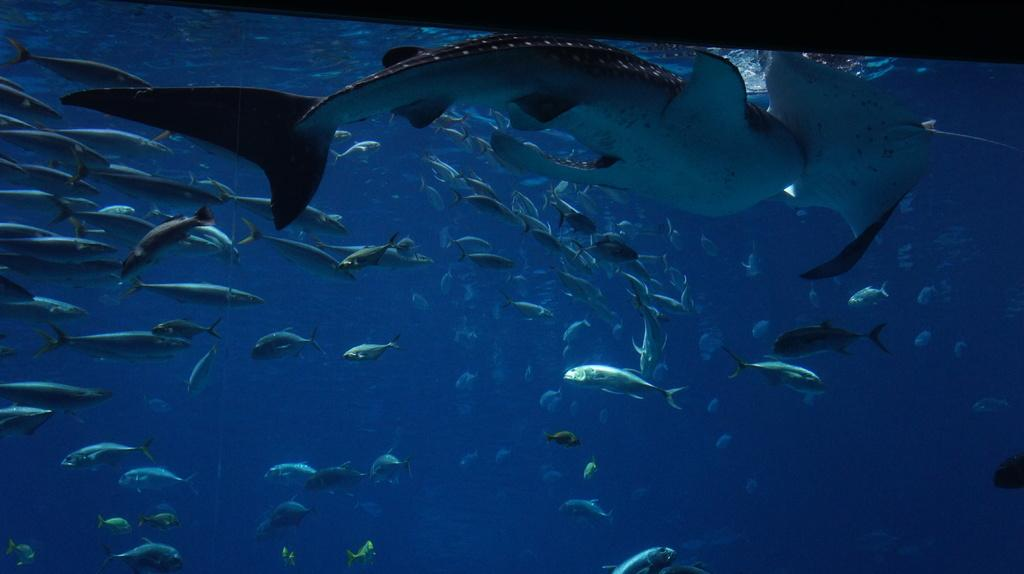What type of animals can be seen in the image? There are fishes and marine creatures in the image. What are the fishes and marine creatures doing in the image? The fishes and marine creatures are swimming in a water body. Can you describe the environment where the fishes and marine creatures are located? The water body appears to be an aquarium. What type of bell can be heard ringing in the image? There is no bell present or ringing in the image; it features fishes and marine creatures swimming in an aquarium. 